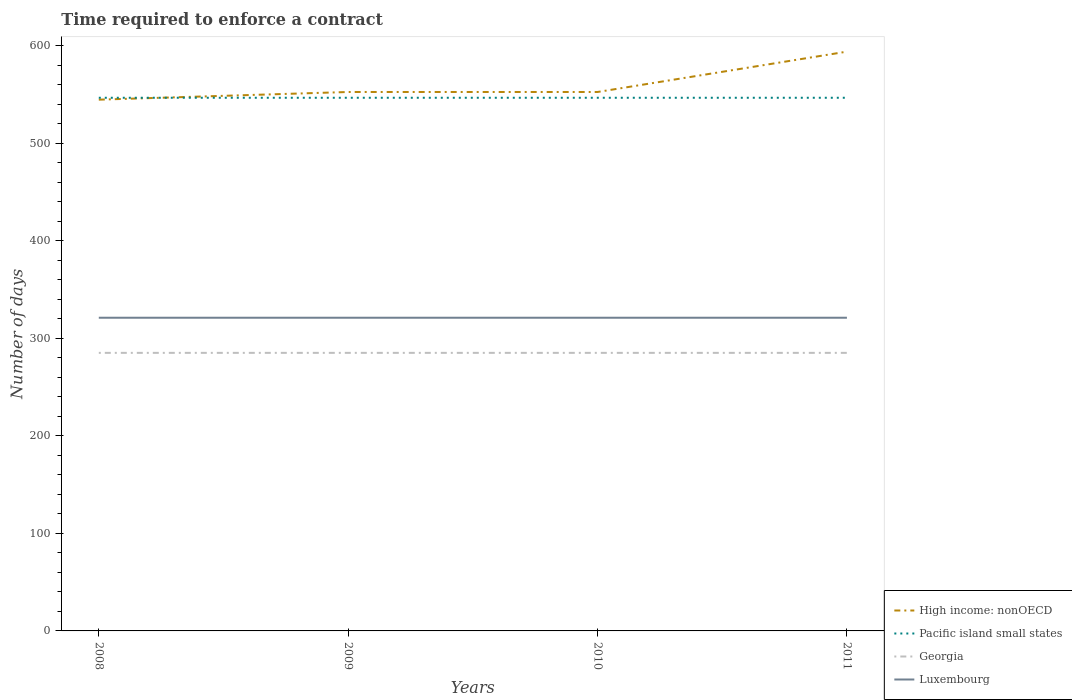Across all years, what is the maximum number of days required to enforce a contract in Luxembourg?
Provide a short and direct response. 321. What is the total number of days required to enforce a contract in Pacific island small states in the graph?
Give a very brief answer. 0. What is the difference between the highest and the second highest number of days required to enforce a contract in Pacific island small states?
Keep it short and to the point. 0. How many lines are there?
Your answer should be compact. 4. How many years are there in the graph?
Provide a short and direct response. 4. Does the graph contain grids?
Offer a terse response. No. How many legend labels are there?
Provide a short and direct response. 4. How are the legend labels stacked?
Keep it short and to the point. Vertical. What is the title of the graph?
Your answer should be very brief. Time required to enforce a contract. What is the label or title of the X-axis?
Your answer should be very brief. Years. What is the label or title of the Y-axis?
Your response must be concise. Number of days. What is the Number of days of High income: nonOECD in 2008?
Your response must be concise. 544.5. What is the Number of days of Pacific island small states in 2008?
Provide a short and direct response. 546.44. What is the Number of days in Georgia in 2008?
Offer a terse response. 285. What is the Number of days in Luxembourg in 2008?
Your response must be concise. 321. What is the Number of days in High income: nonOECD in 2009?
Your response must be concise. 552.38. What is the Number of days of Pacific island small states in 2009?
Make the answer very short. 546.44. What is the Number of days in Georgia in 2009?
Make the answer very short. 285. What is the Number of days in Luxembourg in 2009?
Provide a short and direct response. 321. What is the Number of days in High income: nonOECD in 2010?
Ensure brevity in your answer.  552.38. What is the Number of days of Pacific island small states in 2010?
Make the answer very short. 546.44. What is the Number of days of Georgia in 2010?
Make the answer very short. 285. What is the Number of days in Luxembourg in 2010?
Your answer should be very brief. 321. What is the Number of days in High income: nonOECD in 2011?
Make the answer very short. 593.73. What is the Number of days in Pacific island small states in 2011?
Offer a very short reply. 546.44. What is the Number of days of Georgia in 2011?
Offer a very short reply. 285. What is the Number of days in Luxembourg in 2011?
Offer a terse response. 321. Across all years, what is the maximum Number of days in High income: nonOECD?
Provide a succinct answer. 593.73. Across all years, what is the maximum Number of days in Pacific island small states?
Give a very brief answer. 546.44. Across all years, what is the maximum Number of days in Georgia?
Ensure brevity in your answer.  285. Across all years, what is the maximum Number of days of Luxembourg?
Give a very brief answer. 321. Across all years, what is the minimum Number of days of High income: nonOECD?
Your answer should be very brief. 544.5. Across all years, what is the minimum Number of days in Pacific island small states?
Provide a short and direct response. 546.44. Across all years, what is the minimum Number of days of Georgia?
Your answer should be compact. 285. Across all years, what is the minimum Number of days of Luxembourg?
Offer a very short reply. 321. What is the total Number of days of High income: nonOECD in the graph?
Ensure brevity in your answer.  2242.98. What is the total Number of days of Pacific island small states in the graph?
Keep it short and to the point. 2185.78. What is the total Number of days of Georgia in the graph?
Provide a succinct answer. 1140. What is the total Number of days in Luxembourg in the graph?
Keep it short and to the point. 1284. What is the difference between the Number of days of High income: nonOECD in 2008 and that in 2009?
Your answer should be very brief. -7.88. What is the difference between the Number of days in Luxembourg in 2008 and that in 2009?
Offer a very short reply. 0. What is the difference between the Number of days in High income: nonOECD in 2008 and that in 2010?
Give a very brief answer. -7.88. What is the difference between the Number of days in Pacific island small states in 2008 and that in 2010?
Provide a succinct answer. 0. What is the difference between the Number of days in Georgia in 2008 and that in 2010?
Offer a very short reply. 0. What is the difference between the Number of days in High income: nonOECD in 2008 and that in 2011?
Keep it short and to the point. -49.23. What is the difference between the Number of days in Luxembourg in 2008 and that in 2011?
Your answer should be compact. 0. What is the difference between the Number of days of High income: nonOECD in 2009 and that in 2010?
Ensure brevity in your answer.  0. What is the difference between the Number of days of Pacific island small states in 2009 and that in 2010?
Ensure brevity in your answer.  0. What is the difference between the Number of days in Georgia in 2009 and that in 2010?
Offer a very short reply. 0. What is the difference between the Number of days of High income: nonOECD in 2009 and that in 2011?
Your answer should be very brief. -41.36. What is the difference between the Number of days of Luxembourg in 2009 and that in 2011?
Provide a short and direct response. 0. What is the difference between the Number of days in High income: nonOECD in 2010 and that in 2011?
Offer a very short reply. -41.36. What is the difference between the Number of days in Pacific island small states in 2010 and that in 2011?
Offer a terse response. 0. What is the difference between the Number of days in High income: nonOECD in 2008 and the Number of days in Pacific island small states in 2009?
Give a very brief answer. -1.94. What is the difference between the Number of days in High income: nonOECD in 2008 and the Number of days in Georgia in 2009?
Offer a very short reply. 259.5. What is the difference between the Number of days of High income: nonOECD in 2008 and the Number of days of Luxembourg in 2009?
Your response must be concise. 223.5. What is the difference between the Number of days in Pacific island small states in 2008 and the Number of days in Georgia in 2009?
Keep it short and to the point. 261.44. What is the difference between the Number of days of Pacific island small states in 2008 and the Number of days of Luxembourg in 2009?
Offer a very short reply. 225.44. What is the difference between the Number of days in Georgia in 2008 and the Number of days in Luxembourg in 2009?
Offer a terse response. -36. What is the difference between the Number of days of High income: nonOECD in 2008 and the Number of days of Pacific island small states in 2010?
Offer a very short reply. -1.94. What is the difference between the Number of days in High income: nonOECD in 2008 and the Number of days in Georgia in 2010?
Offer a terse response. 259.5. What is the difference between the Number of days of High income: nonOECD in 2008 and the Number of days of Luxembourg in 2010?
Keep it short and to the point. 223.5. What is the difference between the Number of days in Pacific island small states in 2008 and the Number of days in Georgia in 2010?
Give a very brief answer. 261.44. What is the difference between the Number of days of Pacific island small states in 2008 and the Number of days of Luxembourg in 2010?
Offer a terse response. 225.44. What is the difference between the Number of days of Georgia in 2008 and the Number of days of Luxembourg in 2010?
Provide a succinct answer. -36. What is the difference between the Number of days of High income: nonOECD in 2008 and the Number of days of Pacific island small states in 2011?
Ensure brevity in your answer.  -1.94. What is the difference between the Number of days of High income: nonOECD in 2008 and the Number of days of Georgia in 2011?
Your response must be concise. 259.5. What is the difference between the Number of days of High income: nonOECD in 2008 and the Number of days of Luxembourg in 2011?
Offer a terse response. 223.5. What is the difference between the Number of days in Pacific island small states in 2008 and the Number of days in Georgia in 2011?
Your answer should be compact. 261.44. What is the difference between the Number of days in Pacific island small states in 2008 and the Number of days in Luxembourg in 2011?
Provide a succinct answer. 225.44. What is the difference between the Number of days in Georgia in 2008 and the Number of days in Luxembourg in 2011?
Keep it short and to the point. -36. What is the difference between the Number of days in High income: nonOECD in 2009 and the Number of days in Pacific island small states in 2010?
Provide a short and direct response. 5.93. What is the difference between the Number of days in High income: nonOECD in 2009 and the Number of days in Georgia in 2010?
Offer a terse response. 267.38. What is the difference between the Number of days of High income: nonOECD in 2009 and the Number of days of Luxembourg in 2010?
Ensure brevity in your answer.  231.38. What is the difference between the Number of days in Pacific island small states in 2009 and the Number of days in Georgia in 2010?
Provide a short and direct response. 261.44. What is the difference between the Number of days of Pacific island small states in 2009 and the Number of days of Luxembourg in 2010?
Ensure brevity in your answer.  225.44. What is the difference between the Number of days of Georgia in 2009 and the Number of days of Luxembourg in 2010?
Offer a very short reply. -36. What is the difference between the Number of days of High income: nonOECD in 2009 and the Number of days of Pacific island small states in 2011?
Make the answer very short. 5.93. What is the difference between the Number of days of High income: nonOECD in 2009 and the Number of days of Georgia in 2011?
Your response must be concise. 267.38. What is the difference between the Number of days of High income: nonOECD in 2009 and the Number of days of Luxembourg in 2011?
Your response must be concise. 231.38. What is the difference between the Number of days in Pacific island small states in 2009 and the Number of days in Georgia in 2011?
Provide a short and direct response. 261.44. What is the difference between the Number of days in Pacific island small states in 2009 and the Number of days in Luxembourg in 2011?
Provide a succinct answer. 225.44. What is the difference between the Number of days in Georgia in 2009 and the Number of days in Luxembourg in 2011?
Offer a terse response. -36. What is the difference between the Number of days in High income: nonOECD in 2010 and the Number of days in Pacific island small states in 2011?
Provide a succinct answer. 5.93. What is the difference between the Number of days in High income: nonOECD in 2010 and the Number of days in Georgia in 2011?
Offer a very short reply. 267.38. What is the difference between the Number of days of High income: nonOECD in 2010 and the Number of days of Luxembourg in 2011?
Make the answer very short. 231.38. What is the difference between the Number of days of Pacific island small states in 2010 and the Number of days of Georgia in 2011?
Your response must be concise. 261.44. What is the difference between the Number of days in Pacific island small states in 2010 and the Number of days in Luxembourg in 2011?
Keep it short and to the point. 225.44. What is the difference between the Number of days of Georgia in 2010 and the Number of days of Luxembourg in 2011?
Provide a short and direct response. -36. What is the average Number of days in High income: nonOECD per year?
Offer a very short reply. 560.75. What is the average Number of days in Pacific island small states per year?
Offer a very short reply. 546.44. What is the average Number of days in Georgia per year?
Your answer should be compact. 285. What is the average Number of days in Luxembourg per year?
Provide a succinct answer. 321. In the year 2008, what is the difference between the Number of days of High income: nonOECD and Number of days of Pacific island small states?
Make the answer very short. -1.94. In the year 2008, what is the difference between the Number of days in High income: nonOECD and Number of days in Georgia?
Offer a very short reply. 259.5. In the year 2008, what is the difference between the Number of days of High income: nonOECD and Number of days of Luxembourg?
Ensure brevity in your answer.  223.5. In the year 2008, what is the difference between the Number of days in Pacific island small states and Number of days in Georgia?
Your answer should be very brief. 261.44. In the year 2008, what is the difference between the Number of days in Pacific island small states and Number of days in Luxembourg?
Give a very brief answer. 225.44. In the year 2008, what is the difference between the Number of days of Georgia and Number of days of Luxembourg?
Provide a short and direct response. -36. In the year 2009, what is the difference between the Number of days in High income: nonOECD and Number of days in Pacific island small states?
Ensure brevity in your answer.  5.93. In the year 2009, what is the difference between the Number of days of High income: nonOECD and Number of days of Georgia?
Ensure brevity in your answer.  267.38. In the year 2009, what is the difference between the Number of days of High income: nonOECD and Number of days of Luxembourg?
Your answer should be very brief. 231.38. In the year 2009, what is the difference between the Number of days in Pacific island small states and Number of days in Georgia?
Provide a short and direct response. 261.44. In the year 2009, what is the difference between the Number of days of Pacific island small states and Number of days of Luxembourg?
Your answer should be very brief. 225.44. In the year 2009, what is the difference between the Number of days in Georgia and Number of days in Luxembourg?
Keep it short and to the point. -36. In the year 2010, what is the difference between the Number of days of High income: nonOECD and Number of days of Pacific island small states?
Ensure brevity in your answer.  5.93. In the year 2010, what is the difference between the Number of days of High income: nonOECD and Number of days of Georgia?
Give a very brief answer. 267.38. In the year 2010, what is the difference between the Number of days in High income: nonOECD and Number of days in Luxembourg?
Your answer should be compact. 231.38. In the year 2010, what is the difference between the Number of days of Pacific island small states and Number of days of Georgia?
Your answer should be compact. 261.44. In the year 2010, what is the difference between the Number of days of Pacific island small states and Number of days of Luxembourg?
Ensure brevity in your answer.  225.44. In the year 2010, what is the difference between the Number of days of Georgia and Number of days of Luxembourg?
Offer a terse response. -36. In the year 2011, what is the difference between the Number of days in High income: nonOECD and Number of days in Pacific island small states?
Provide a succinct answer. 47.29. In the year 2011, what is the difference between the Number of days in High income: nonOECD and Number of days in Georgia?
Make the answer very short. 308.73. In the year 2011, what is the difference between the Number of days of High income: nonOECD and Number of days of Luxembourg?
Provide a succinct answer. 272.73. In the year 2011, what is the difference between the Number of days of Pacific island small states and Number of days of Georgia?
Provide a short and direct response. 261.44. In the year 2011, what is the difference between the Number of days of Pacific island small states and Number of days of Luxembourg?
Your answer should be compact. 225.44. In the year 2011, what is the difference between the Number of days of Georgia and Number of days of Luxembourg?
Give a very brief answer. -36. What is the ratio of the Number of days in High income: nonOECD in 2008 to that in 2009?
Your answer should be very brief. 0.99. What is the ratio of the Number of days in Luxembourg in 2008 to that in 2009?
Make the answer very short. 1. What is the ratio of the Number of days of High income: nonOECD in 2008 to that in 2010?
Provide a short and direct response. 0.99. What is the ratio of the Number of days of Georgia in 2008 to that in 2010?
Your answer should be very brief. 1. What is the ratio of the Number of days of High income: nonOECD in 2008 to that in 2011?
Provide a short and direct response. 0.92. What is the ratio of the Number of days of Luxembourg in 2008 to that in 2011?
Your answer should be very brief. 1. What is the ratio of the Number of days in High income: nonOECD in 2009 to that in 2011?
Offer a very short reply. 0.93. What is the ratio of the Number of days in Pacific island small states in 2009 to that in 2011?
Your answer should be compact. 1. What is the ratio of the Number of days of Georgia in 2009 to that in 2011?
Give a very brief answer. 1. What is the ratio of the Number of days in Luxembourg in 2009 to that in 2011?
Offer a terse response. 1. What is the ratio of the Number of days of High income: nonOECD in 2010 to that in 2011?
Offer a very short reply. 0.93. What is the ratio of the Number of days in Pacific island small states in 2010 to that in 2011?
Offer a very short reply. 1. What is the difference between the highest and the second highest Number of days in High income: nonOECD?
Offer a terse response. 41.36. What is the difference between the highest and the second highest Number of days in Georgia?
Your response must be concise. 0. What is the difference between the highest and the second highest Number of days in Luxembourg?
Your response must be concise. 0. What is the difference between the highest and the lowest Number of days in High income: nonOECD?
Keep it short and to the point. 49.23. What is the difference between the highest and the lowest Number of days of Luxembourg?
Your answer should be very brief. 0. 